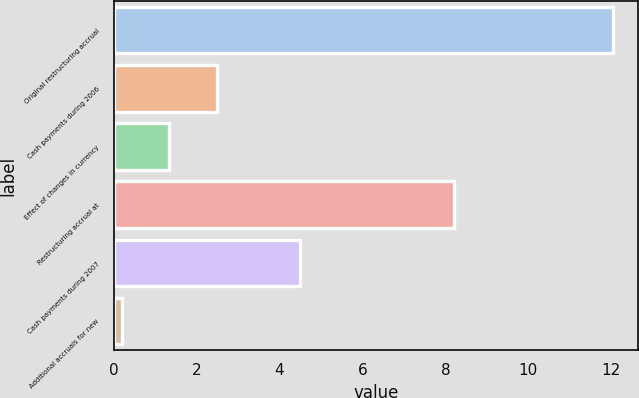Convert chart. <chart><loc_0><loc_0><loc_500><loc_500><bar_chart><fcel>Original restructuring accrual<fcel>Cash payments during 2006<fcel>Effect of changes in currency<fcel>Restructuring accrual at<fcel>Cash payments during 2007<fcel>Additional accruals for new<nl><fcel>12.04<fcel>2.48<fcel>1.34<fcel>8.2<fcel>4.5<fcel>0.2<nl></chart> 